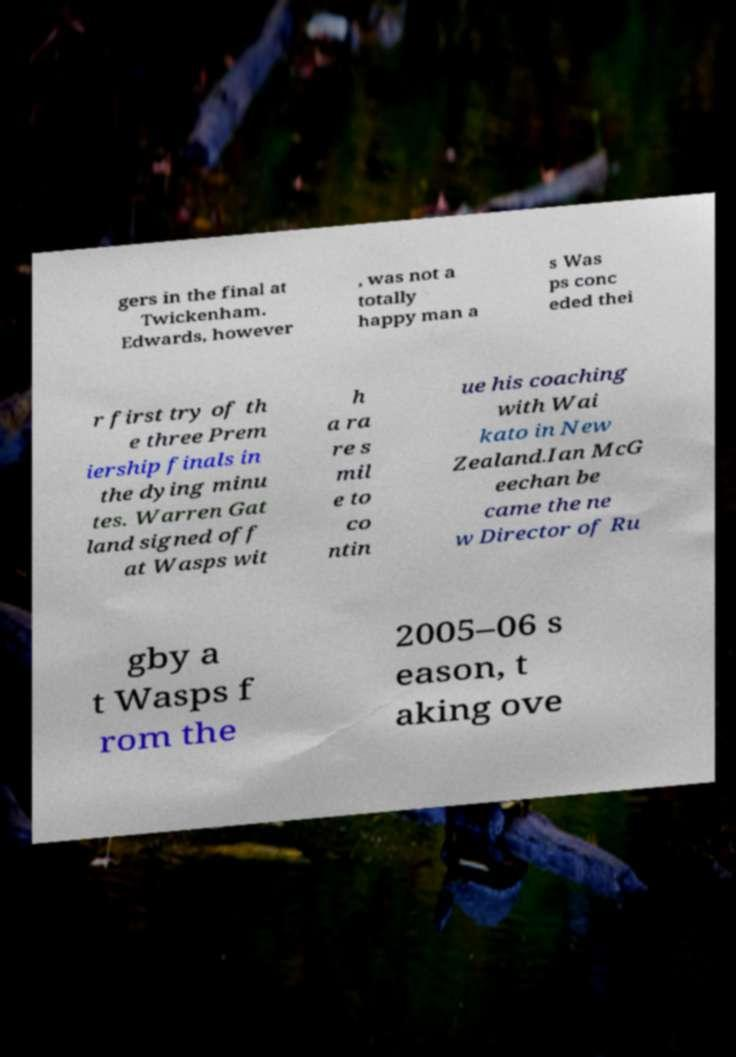For documentation purposes, I need the text within this image transcribed. Could you provide that? gers in the final at Twickenham. Edwards, however , was not a totally happy man a s Was ps conc eded thei r first try of th e three Prem iership finals in the dying minu tes. Warren Gat land signed off at Wasps wit h a ra re s mil e to co ntin ue his coaching with Wai kato in New Zealand.Ian McG eechan be came the ne w Director of Ru gby a t Wasps f rom the 2005–06 s eason, t aking ove 